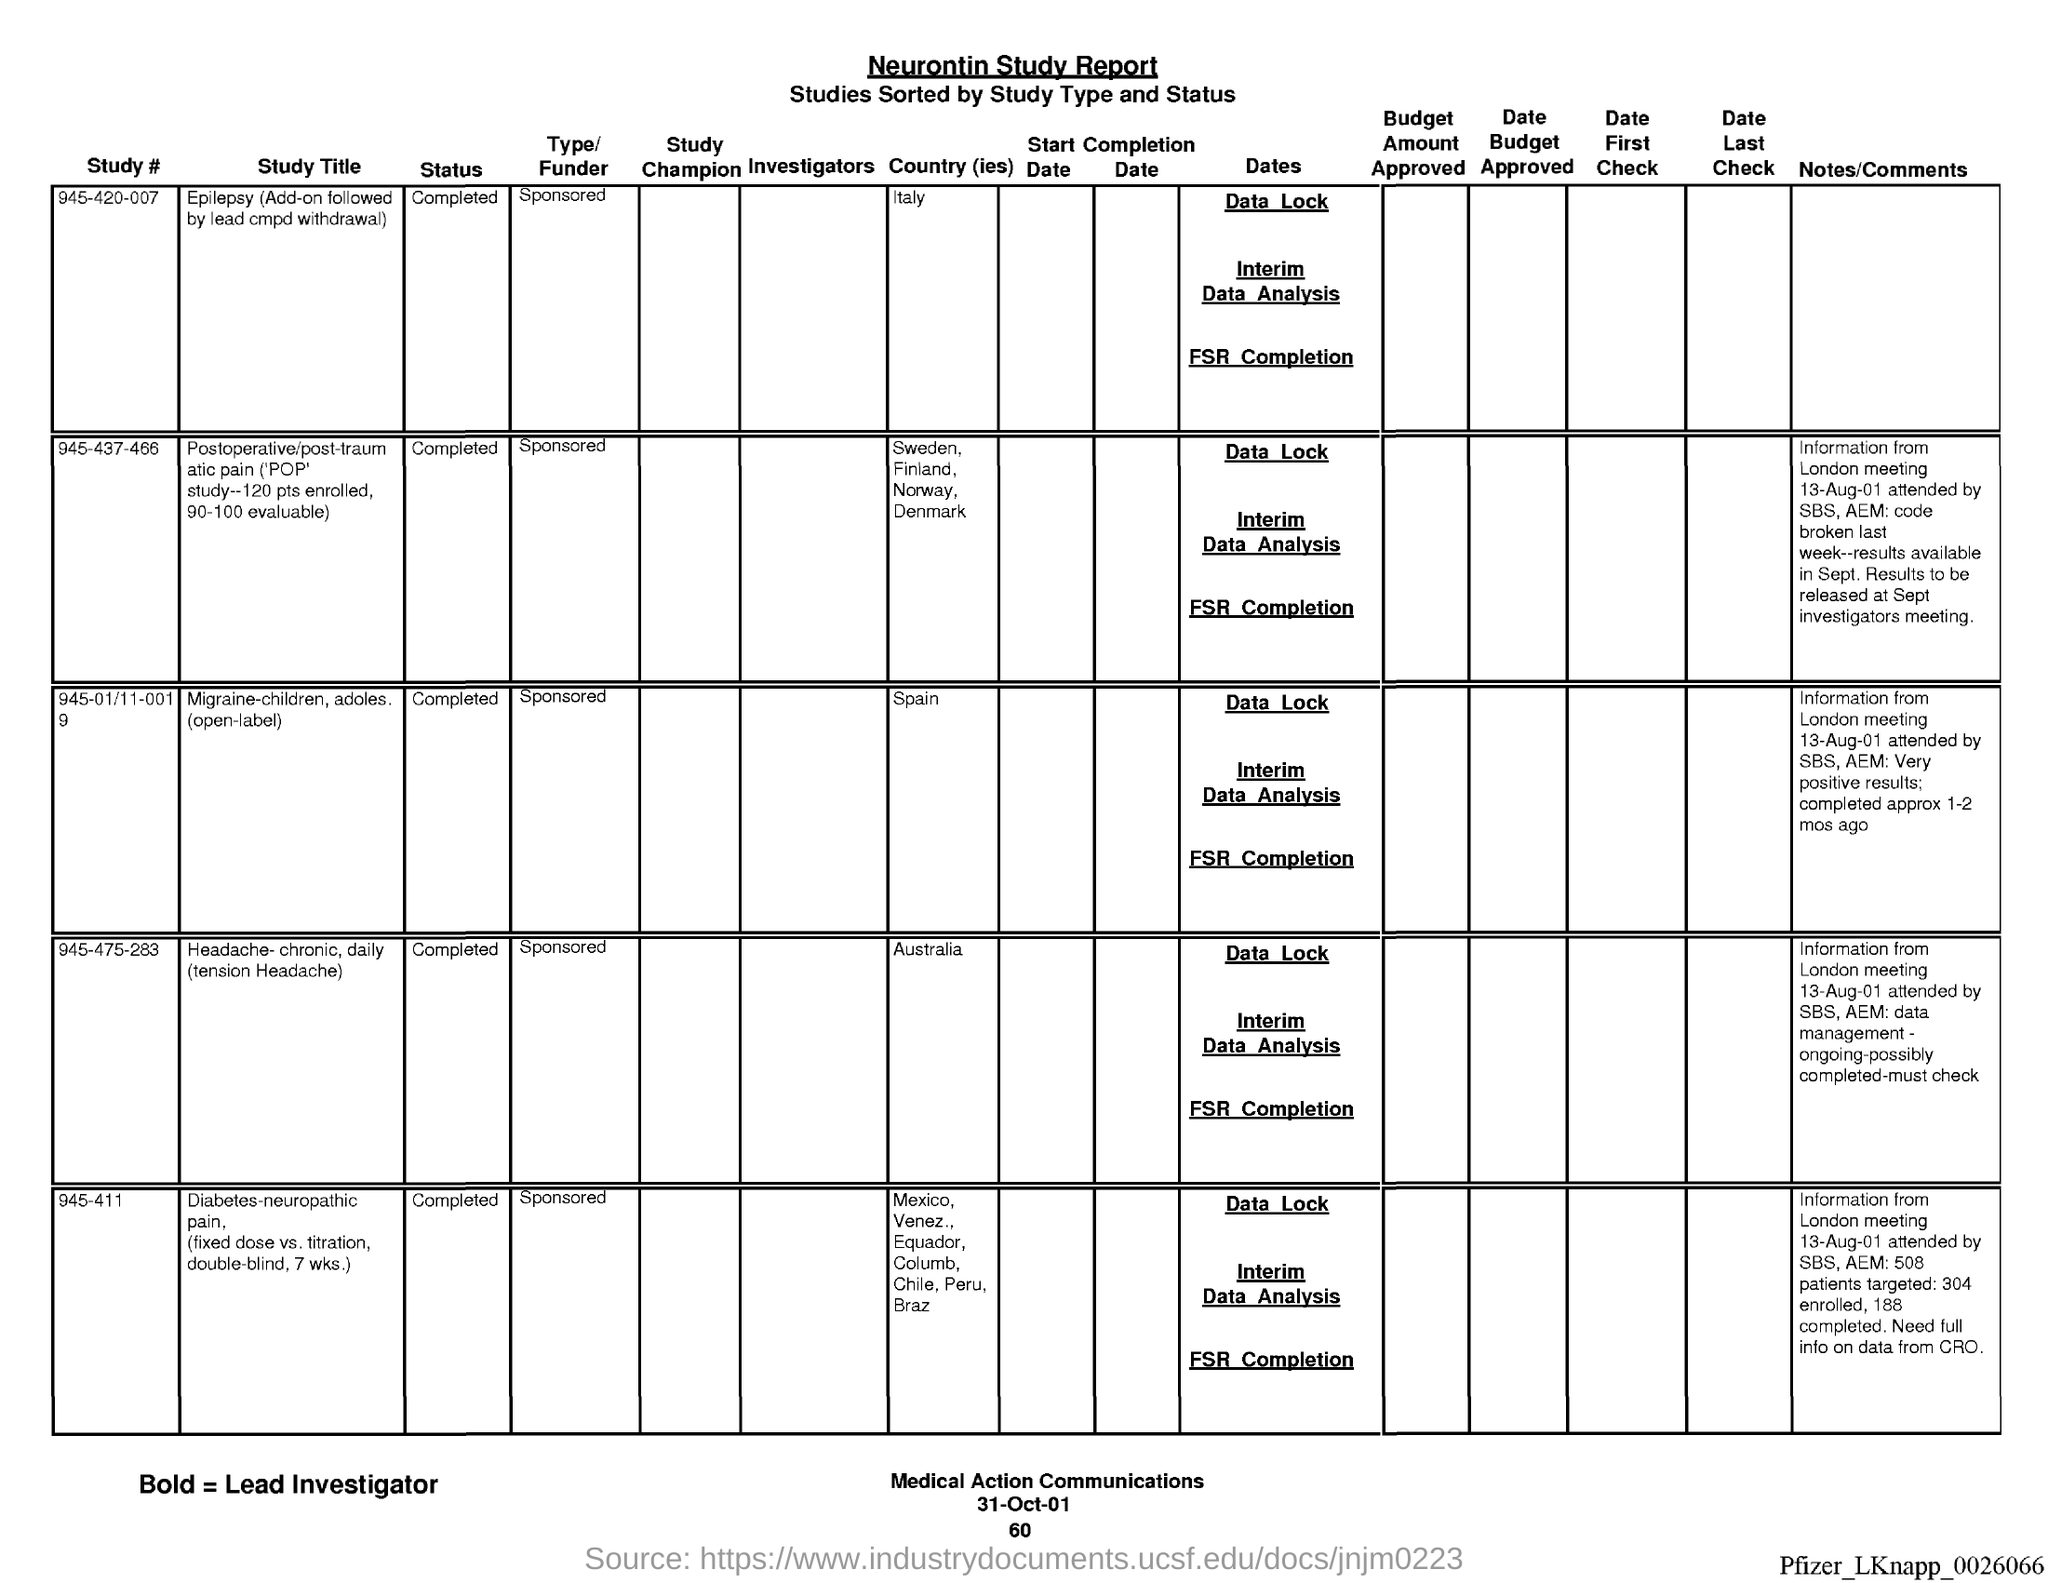List a handful of essential elements in this visual. The title of the document is the Neurontin Study Report. The study with the identifier #945-01/11-0019 has been completed. The country for study number #945-420-007 is Italy. The date on the document is October 31, 2001. Study #945-01/11-0019 is about the country of Spain. 